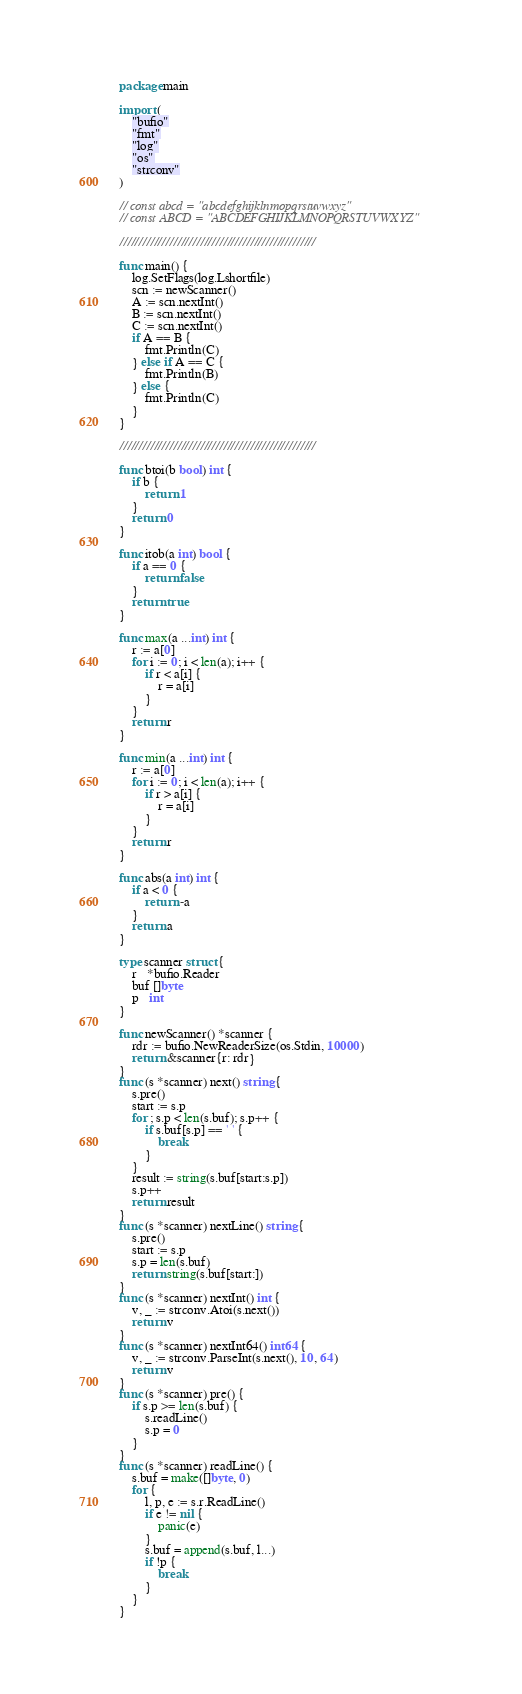Convert code to text. <code><loc_0><loc_0><loc_500><loc_500><_Go_>package main

import (
	"bufio"
	"fmt"
	"log"
	"os"
	"strconv"
)

// const abcd = "abcdefghijklnmopqrstuvwxyz"
// const ABCD = "ABCDEFGHIJKLMNOPQRSTUVWXYZ"

///////////////////////////////////////////////////

func main() {
	log.SetFlags(log.Lshortfile)
	scn := newScanner()
	A := scn.nextInt()
	B := scn.nextInt()
	C := scn.nextInt()
	if A == B {
		fmt.Println(C)
	} else if A == C {
		fmt.Println(B)
	} else {
		fmt.Println(C)
	}
}

///////////////////////////////////////////////////

func btoi(b bool) int {
	if b {
		return 1
	}
	return 0
}

func itob(a int) bool {
	if a == 0 {
		return false
	}
	return true
}

func max(a ...int) int {
	r := a[0]
	for i := 0; i < len(a); i++ {
		if r < a[i] {
			r = a[i]
		}
	}
	return r
}

func min(a ...int) int {
	r := a[0]
	for i := 0; i < len(a); i++ {
		if r > a[i] {
			r = a[i]
		}
	}
	return r
}

func abs(a int) int {
	if a < 0 {
		return -a
	}
	return a
}

type scanner struct {
	r   *bufio.Reader
	buf []byte
	p   int
}

func newScanner() *scanner {
	rdr := bufio.NewReaderSize(os.Stdin, 10000)
	return &scanner{r: rdr}
}
func (s *scanner) next() string {
	s.pre()
	start := s.p
	for ; s.p < len(s.buf); s.p++ {
		if s.buf[s.p] == ' ' {
			break
		}
	}
	result := string(s.buf[start:s.p])
	s.p++
	return result
}
func (s *scanner) nextLine() string {
	s.pre()
	start := s.p
	s.p = len(s.buf)
	return string(s.buf[start:])
}
func (s *scanner) nextInt() int {
	v, _ := strconv.Atoi(s.next())
	return v
}
func (s *scanner) nextInt64() int64 {
	v, _ := strconv.ParseInt(s.next(), 10, 64)
	return v
}
func (s *scanner) pre() {
	if s.p >= len(s.buf) {
		s.readLine()
		s.p = 0
	}
}
func (s *scanner) readLine() {
	s.buf = make([]byte, 0)
	for {
		l, p, e := s.r.ReadLine()
		if e != nil {
			panic(e)
		}
		s.buf = append(s.buf, l...)
		if !p {
			break
		}
	}
}
</code> 